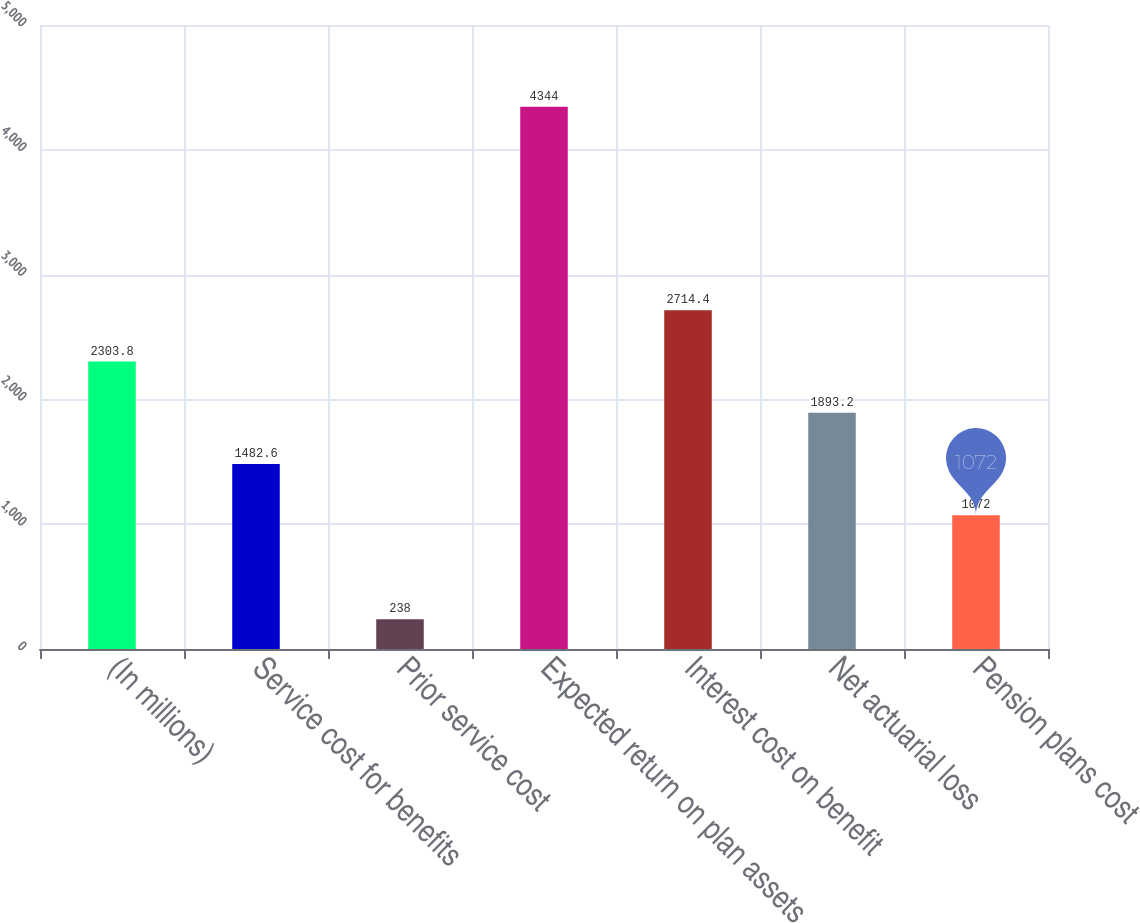Convert chart. <chart><loc_0><loc_0><loc_500><loc_500><bar_chart><fcel>(In millions)<fcel>Service cost for benefits<fcel>Prior service cost<fcel>Expected return on plan assets<fcel>Interest cost on benefit<fcel>Net actuarial loss<fcel>Pension plans cost<nl><fcel>2303.8<fcel>1482.6<fcel>238<fcel>4344<fcel>2714.4<fcel>1893.2<fcel>1072<nl></chart> 